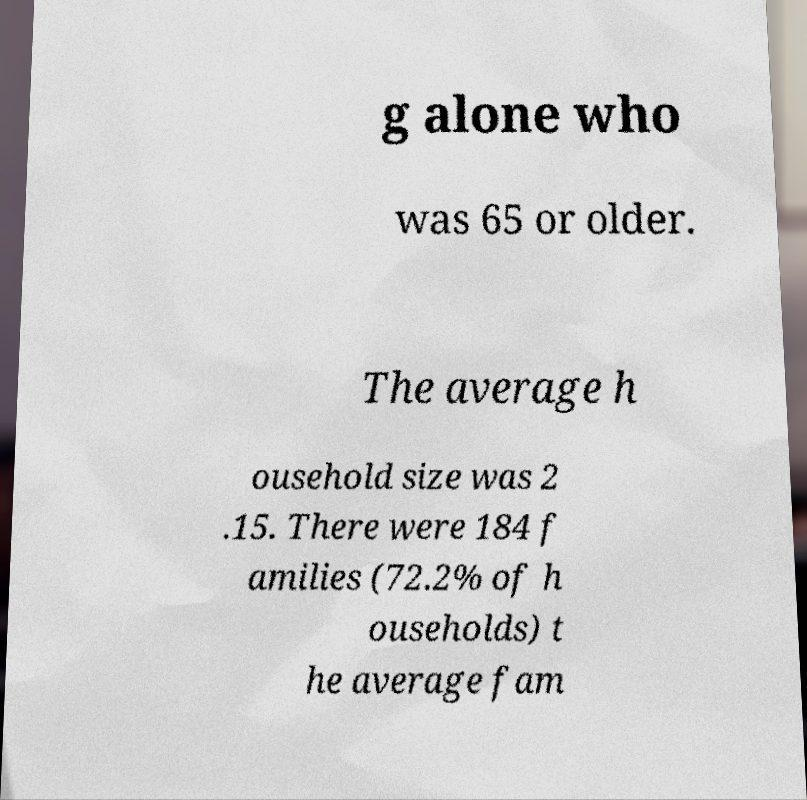What messages or text are displayed in this image? I need them in a readable, typed format. g alone who was 65 or older. The average h ousehold size was 2 .15. There were 184 f amilies (72.2% of h ouseholds) t he average fam 